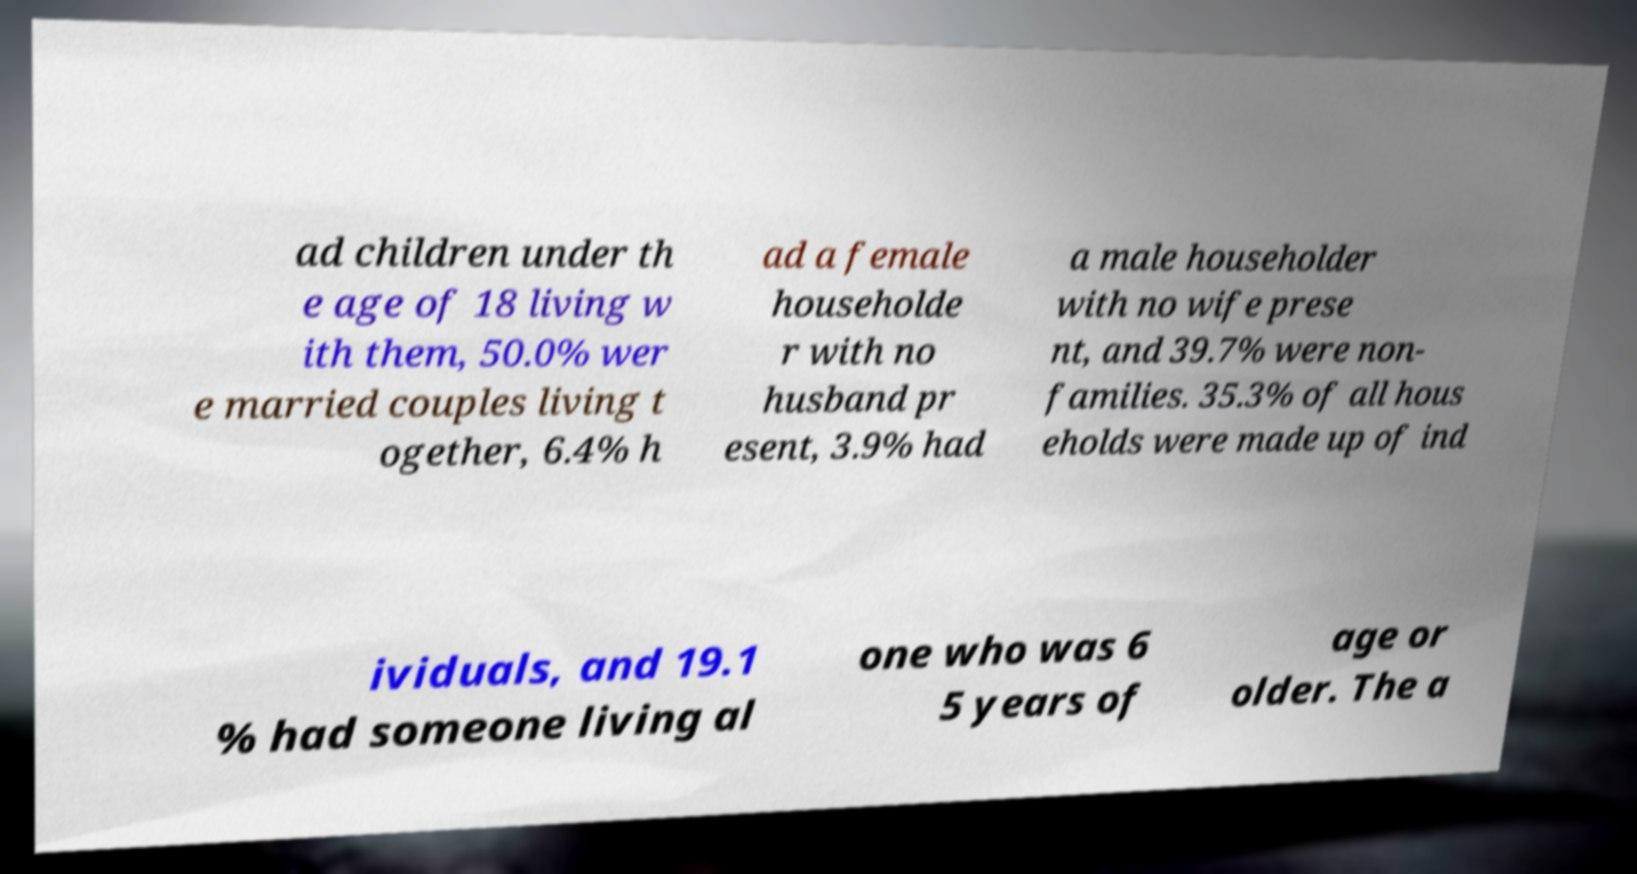Can you accurately transcribe the text from the provided image for me? ad children under th e age of 18 living w ith them, 50.0% wer e married couples living t ogether, 6.4% h ad a female householde r with no husband pr esent, 3.9% had a male householder with no wife prese nt, and 39.7% were non- families. 35.3% of all hous eholds were made up of ind ividuals, and 19.1 % had someone living al one who was 6 5 years of age or older. The a 